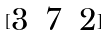<formula> <loc_0><loc_0><loc_500><loc_500>[ \begin{matrix} 3 & 7 & 2 \end{matrix} ]</formula> 